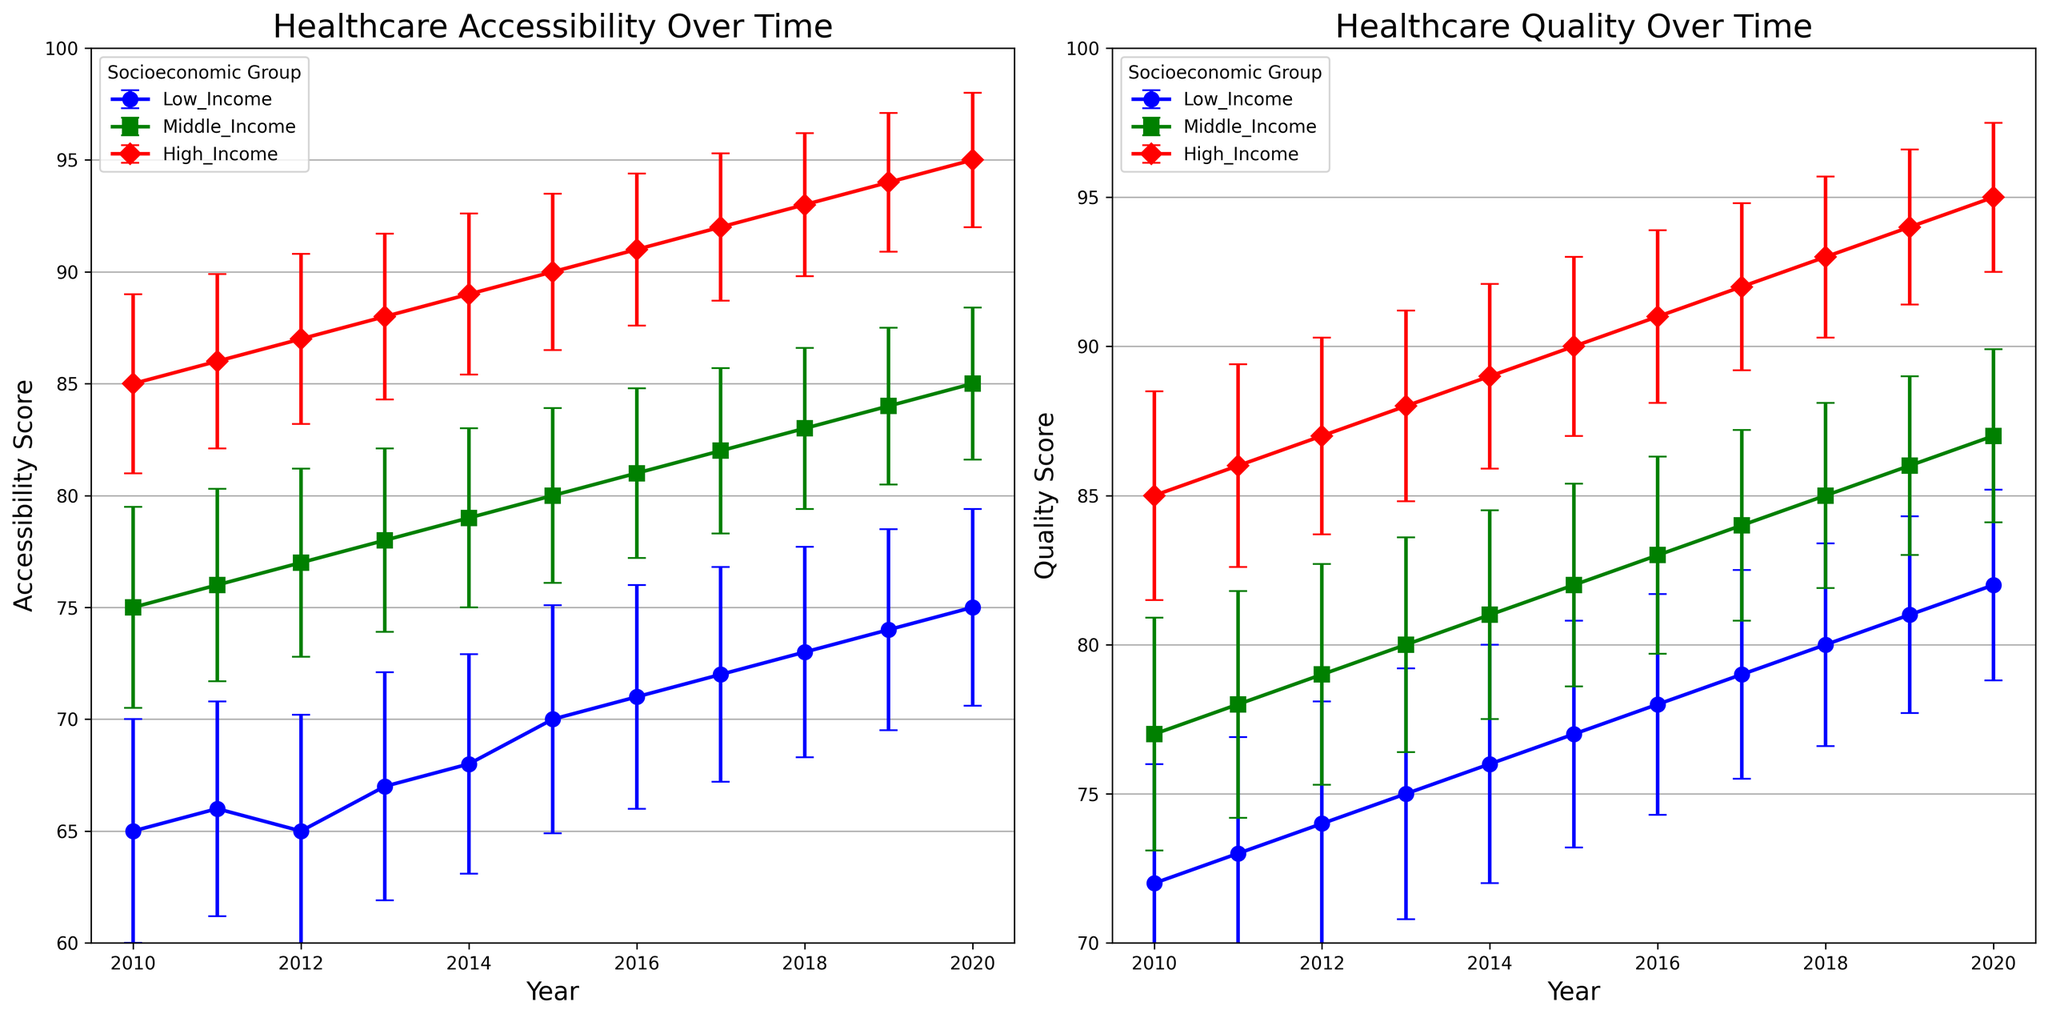Which socioeconomic group showed the most significant increase in healthcare accessibility from 2010 to 2020? To answer this, we subtract the 2010 accessibility mean from the 2020 accessibility mean for each group and compare the results. Low_Income: 75-65 = 10, Middle_Income: 85-75 = 10, High_Income: 95-85 = 10. All groups showed an equivalent increase of 10 points.
Answer: All groups Comparing 2020 accessibility scores, which socioeconomic group leads in healthcare accessibility? We directly compare the 2020 accessibility scores for each group. Low_Income: 75, Middle_Income: 85, High_Income: 95. The High_Income group has the highest score.
Answer: High_Income Which group had the smallest error in healthcare quality measurements in the year 2020? Looking at the 2020 quality error bars across groups, we have Low_Income: 3.2, Middle_Income: 2.9, High_Income: 2.5. The High_Income group had the smallest error.
Answer: High_Income In which year did Middle_Income and High_Income groups have an equal quality score? We look for a year where both groups' quality means are equal. In 2013, both Middle_Income and High_Income groups had a quality score of 80 and 88, respectively. There isn't any year where both means are equal, so this did not occur.
Answer: No year What is the average healthcare quality score for the Low_Income group from 2010 to 2020? We calculate the sum of the quality scores from 2010 to 2020 (72 + 73 + 74 + 75 + 76 + 77 + 78 + 79 + 80 + 81 + 82) = 847, and then divide by 11 (number of years) to get the average. 847/11 ≈ 77.
Answer: 77 Which group showed the least fluctuation in healthcare quality scores from 2010 to 2020, based on their error bars? The magnitude of error bars indicates fluctuation. Calculating the average error across years: Low_Income ≈ 3.86, Middle_Income ≈ 3.42, High_Income ≈ 3.04. The High_Income group had the least fluctuation in quality scores.
Answer: High_Income How much did healthcare quality increase for the Middle_Income group from 2013 to 2016? Subtract the 2013 quality score from the 2016 quality score for Middle_Income: 83 - 80 = 3.
Answer: 3 